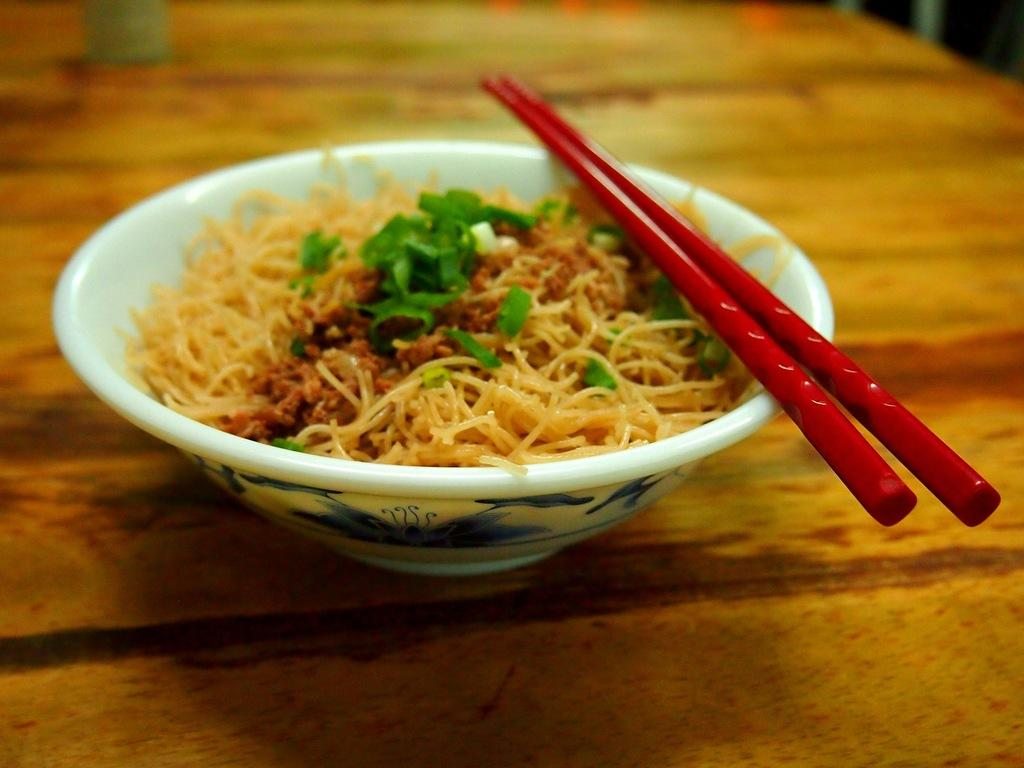What color is the bowl in the image? The bowl in the image is white. What is inside the bowl? The bowl is filled with food. What utensils are present in the image? There are red chopsticks above the bowl. Where is the bowl located? The bowl is placed on a table. What type of rub is being applied to the bowl in the image? There is no rub being applied to the bowl in the image; it is filled with food and has red chopsticks above it. 